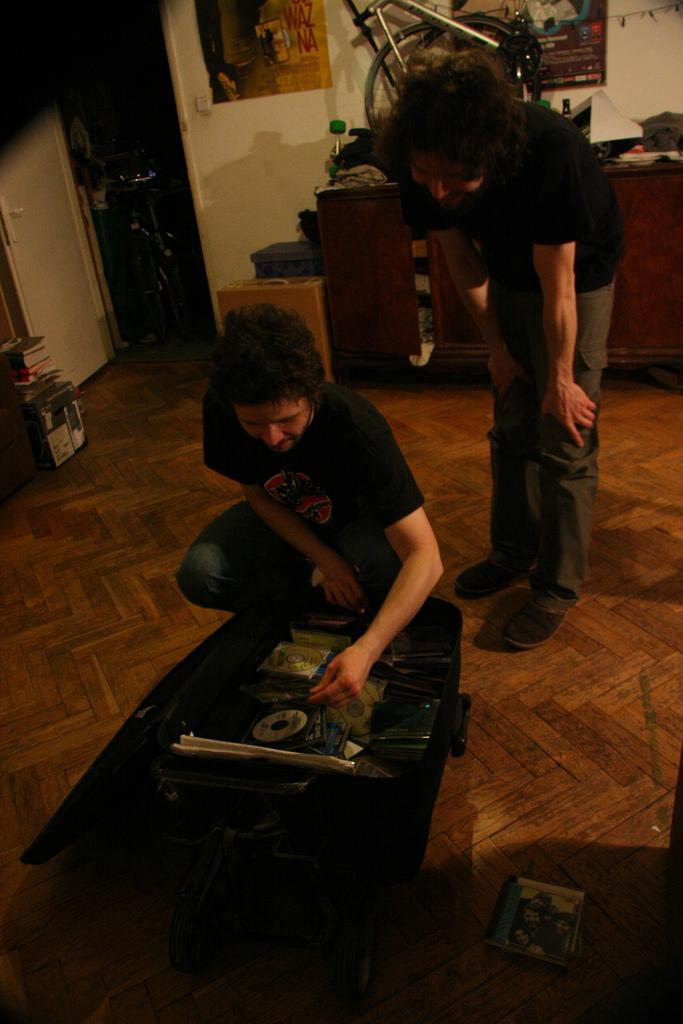Question: why are they bent over?
Choices:
A. To make the bed.
B. To pick something up.
C. To look in the suitcase.
D. To tie their shoe.
Answer with the letter. Answer: C Question: what is on the man's feet?
Choices:
A. Socks.
B. Boots.
C. Sneakers.
D. Shoes.
Answer with the letter. Answer: D Question: what color shirts do the men have?
Choices:
A. Red.
B. White.
C. Blue.
D. Black.
Answer with the letter. Answer: D Question: what is hanging on the wall?
Choices:
A. Posters.
B. Pictures.
C. A keyholder.
D. Jackets.
Answer with the letter. Answer: A Question: where is the suitcase?
Choices:
A. In the closet.
B. On the trolley.
C. In the trunk.
D. On the ground.
Answer with the letter. Answer: D Question: who is looking in the suitcase?
Choices:
A. The lady.
B. The two men.
C. The kids.
D. Two girls.
Answer with the letter. Answer: B Question: where is the bike?
Choices:
A. At the bike rack.
B. Hanging on a wall.
C. In the building.
D. Going down the sidewalk.
Answer with the letter. Answer: B Question: what color is the door?
Choices:
A. Cream colored.
B. Brown.
C. Green.
D. White.
Answer with the letter. Answer: A Question: how many of the men have curly hair?
Choices:
A. Both of them.
B. Two.
C. Three.
D. Four.
Answer with the letter. Answer: A Question: what are the two men browsing?
Choices:
A. Dictionary.
B. Religious books.
C. The cd collection.
D. Latest collection of watches.
Answer with the letter. Answer: C Question: what kind of pants is the man who is standing wearing?
Choices:
A. Black slacks.
B. Dress pants.
C. Running pants.
D. Cargo pants.
Answer with the letter. Answer: D Question: where is the door leading to?
Choices:
A. Another room.
B. The kitchen.
C. The bathroom.
D. The staircase.
Answer with the letter. Answer: A Question: what are piled in a suitcase?
Choices:
A. Cds.
B. Stacks of money.
C. Drugs.
D. Gold bricks.
Answer with the letter. Answer: A Question: where is the cd collection being kept?
Choices:
A. On the shelf.
B. In the room.
C. In a suitcase`.
D. In the car.
Answer with the letter. Answer: C Question: who is wearing jeans?
Choices:
A. The man looking at the cd.
B. The woman watch t.v.
C. The child in school.
D. The man looking at his phone.
Answer with the letter. Answer: A Question: what is cream colored?
Choices:
A. The tablecloth.
B. The wall.
C. The curtains.
D. The building.
Answer with the letter. Answer: B Question: what is the floor made from?
Choices:
A. Carpet.
B. Stone.
C. Wood.
D. Tile.
Answer with the letter. Answer: C Question: what do you see in a stack?
Choices:
A. Books and boxes.
B. Paper.
C. Chairs.
D. Nothing.
Answer with the letter. Answer: A 